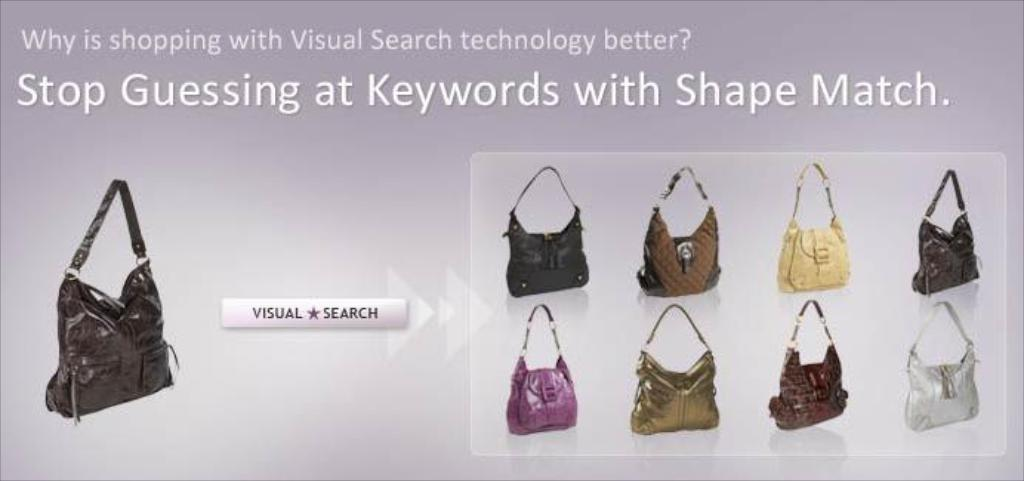What is the main subject of the image? The main subject of the image is a web page. What type of items are displayed on the web page? The web page contains handbags. Can you describe the handbags on the web page? The handbags have various colors. How many mines are visible on the side of the library in the image? There are no mines or libraries present in the image; it features a web page with handbags. 